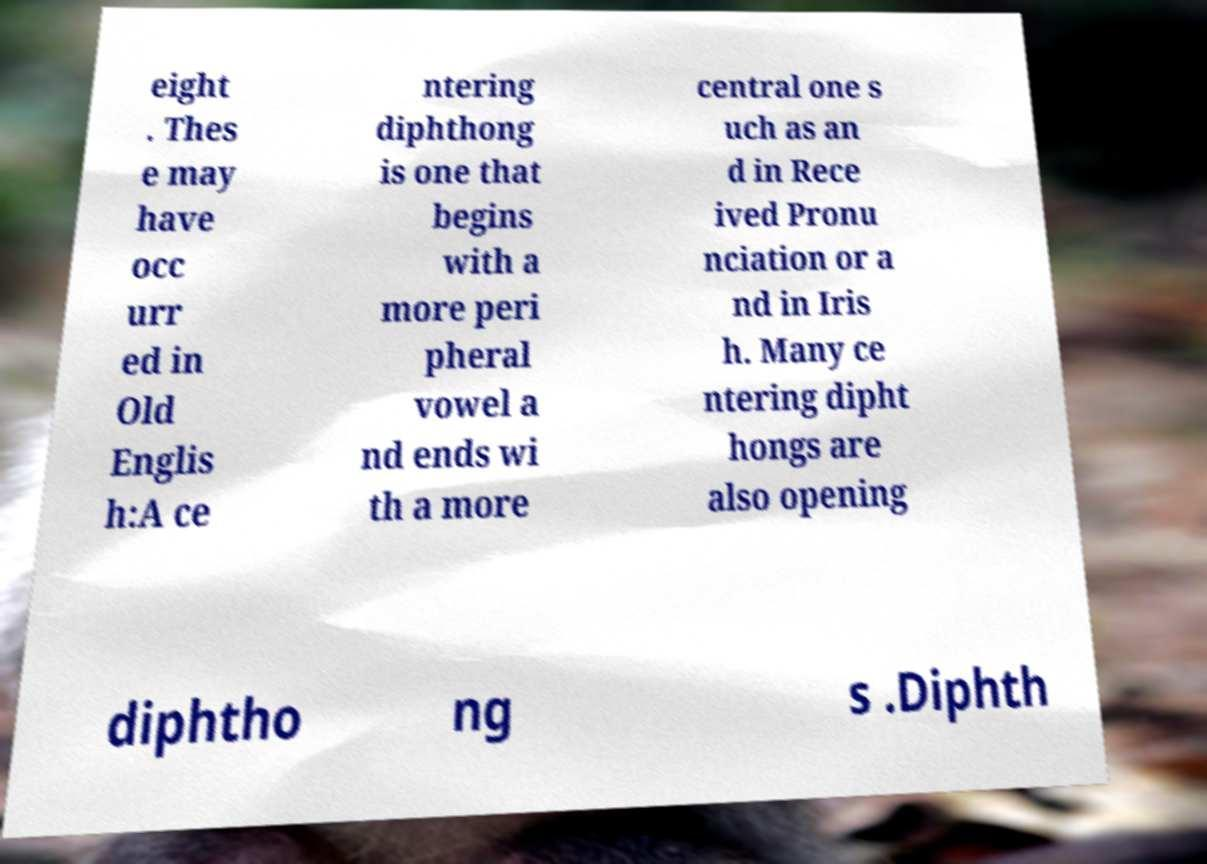Could you extract and type out the text from this image? eight . Thes e may have occ urr ed in Old Englis h:A ce ntering diphthong is one that begins with a more peri pheral vowel a nd ends wi th a more central one s uch as an d in Rece ived Pronu nciation or a nd in Iris h. Many ce ntering dipht hongs are also opening diphtho ng s .Diphth 